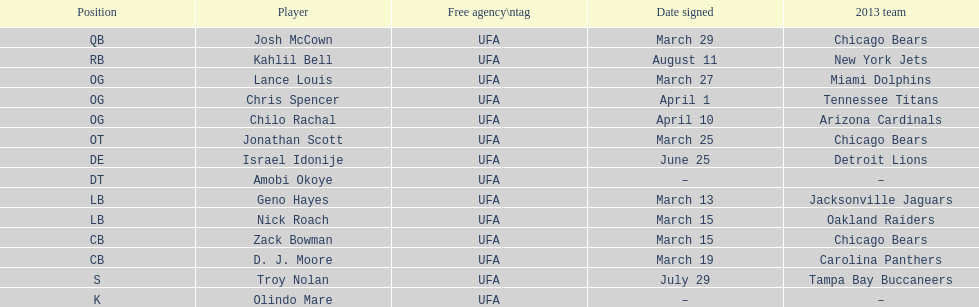Signed the same date as "april fools day". Chris Spencer. 